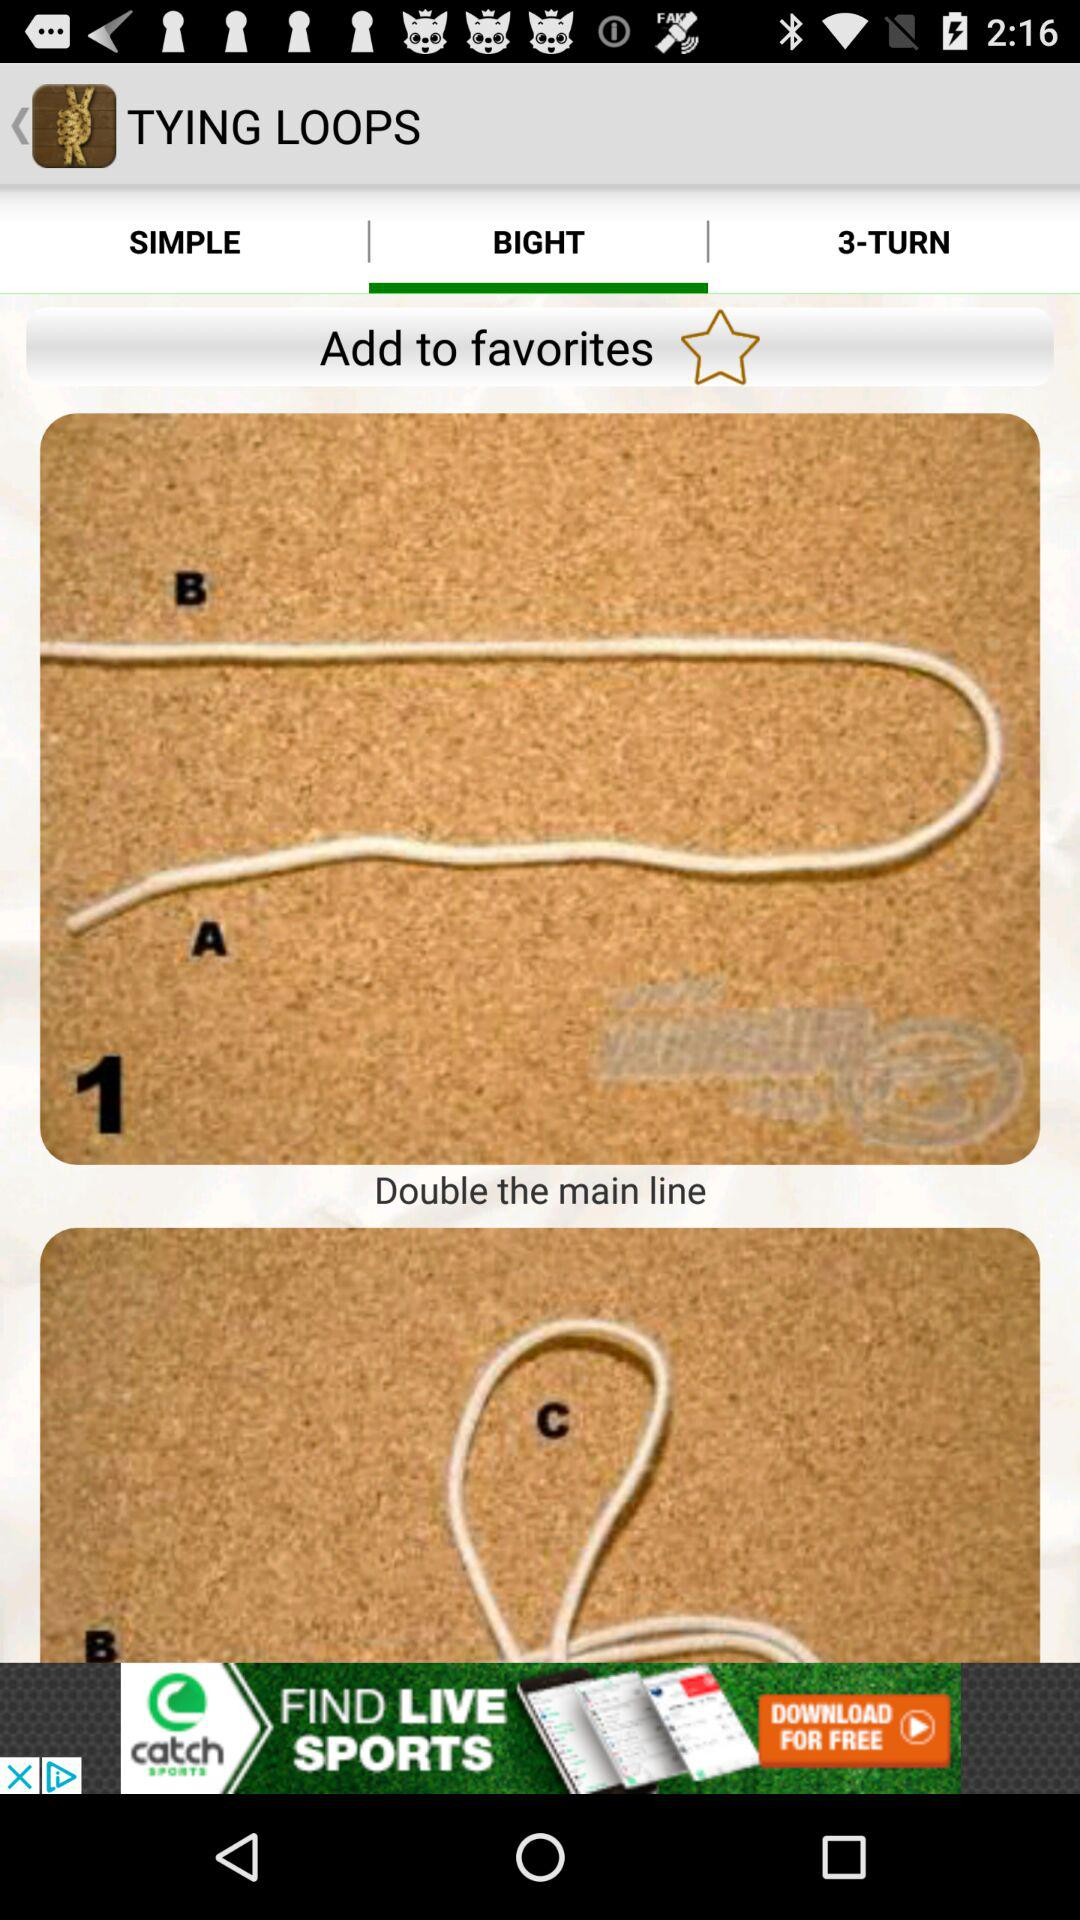What is the name of the application? The name of the application is "Ultimate Fishing Knots". 